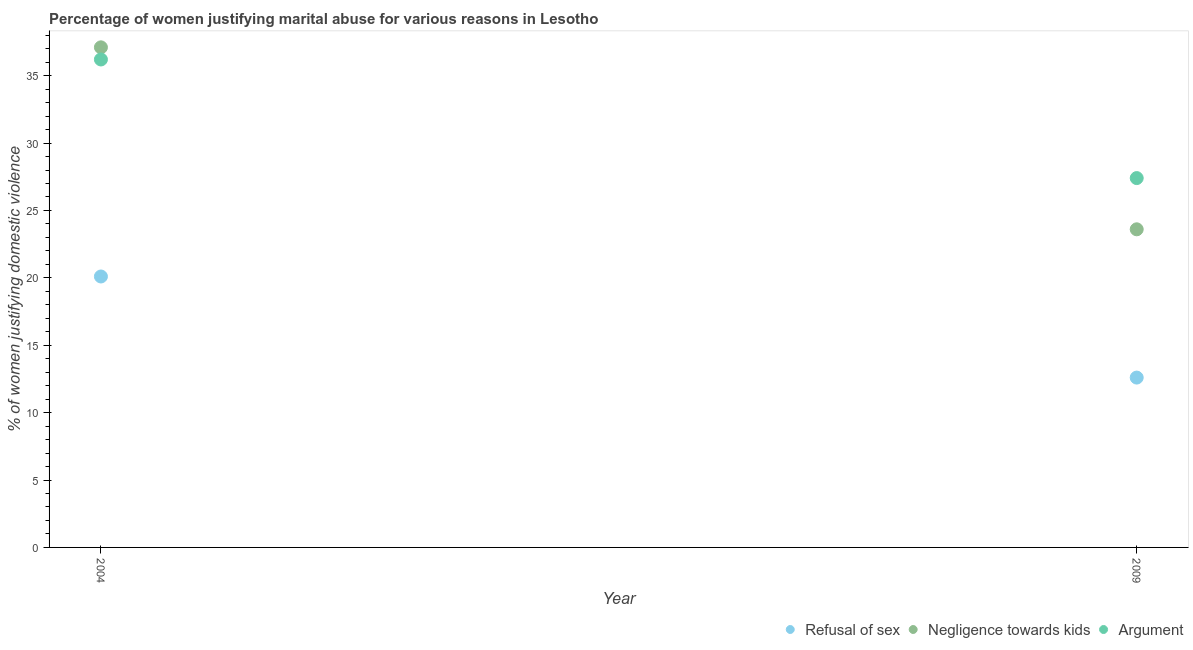Is the number of dotlines equal to the number of legend labels?
Provide a short and direct response. Yes. What is the percentage of women justifying domestic violence due to refusal of sex in 2004?
Your answer should be very brief. 20.1. Across all years, what is the maximum percentage of women justifying domestic violence due to refusal of sex?
Your response must be concise. 20.1. Across all years, what is the minimum percentage of women justifying domestic violence due to negligence towards kids?
Offer a terse response. 23.6. In which year was the percentage of women justifying domestic violence due to arguments maximum?
Make the answer very short. 2004. In which year was the percentage of women justifying domestic violence due to arguments minimum?
Make the answer very short. 2009. What is the total percentage of women justifying domestic violence due to arguments in the graph?
Your answer should be compact. 63.6. What is the difference between the percentage of women justifying domestic violence due to refusal of sex in 2009 and the percentage of women justifying domestic violence due to negligence towards kids in 2004?
Offer a terse response. -24.5. What is the average percentage of women justifying domestic violence due to arguments per year?
Ensure brevity in your answer.  31.8. In the year 2009, what is the difference between the percentage of women justifying domestic violence due to negligence towards kids and percentage of women justifying domestic violence due to refusal of sex?
Provide a short and direct response. 11. What is the ratio of the percentage of women justifying domestic violence due to arguments in 2004 to that in 2009?
Ensure brevity in your answer.  1.32. Is it the case that in every year, the sum of the percentage of women justifying domestic violence due to refusal of sex and percentage of women justifying domestic violence due to negligence towards kids is greater than the percentage of women justifying domestic violence due to arguments?
Your response must be concise. Yes. Does the percentage of women justifying domestic violence due to refusal of sex monotonically increase over the years?
Offer a very short reply. No. How many dotlines are there?
Ensure brevity in your answer.  3. How many years are there in the graph?
Ensure brevity in your answer.  2. What is the difference between two consecutive major ticks on the Y-axis?
Provide a succinct answer. 5. Are the values on the major ticks of Y-axis written in scientific E-notation?
Keep it short and to the point. No. Does the graph contain grids?
Offer a very short reply. No. Where does the legend appear in the graph?
Your answer should be compact. Bottom right. How many legend labels are there?
Ensure brevity in your answer.  3. How are the legend labels stacked?
Make the answer very short. Horizontal. What is the title of the graph?
Ensure brevity in your answer.  Percentage of women justifying marital abuse for various reasons in Lesotho. What is the label or title of the Y-axis?
Give a very brief answer. % of women justifying domestic violence. What is the % of women justifying domestic violence in Refusal of sex in 2004?
Provide a succinct answer. 20.1. What is the % of women justifying domestic violence of Negligence towards kids in 2004?
Ensure brevity in your answer.  37.1. What is the % of women justifying domestic violence of Argument in 2004?
Ensure brevity in your answer.  36.2. What is the % of women justifying domestic violence in Negligence towards kids in 2009?
Keep it short and to the point. 23.6. What is the % of women justifying domestic violence in Argument in 2009?
Keep it short and to the point. 27.4. Across all years, what is the maximum % of women justifying domestic violence of Refusal of sex?
Your answer should be compact. 20.1. Across all years, what is the maximum % of women justifying domestic violence in Negligence towards kids?
Your answer should be very brief. 37.1. Across all years, what is the maximum % of women justifying domestic violence of Argument?
Your answer should be compact. 36.2. Across all years, what is the minimum % of women justifying domestic violence of Negligence towards kids?
Your response must be concise. 23.6. Across all years, what is the minimum % of women justifying domestic violence of Argument?
Ensure brevity in your answer.  27.4. What is the total % of women justifying domestic violence in Refusal of sex in the graph?
Offer a terse response. 32.7. What is the total % of women justifying domestic violence of Negligence towards kids in the graph?
Your answer should be compact. 60.7. What is the total % of women justifying domestic violence of Argument in the graph?
Keep it short and to the point. 63.6. What is the difference between the % of women justifying domestic violence of Negligence towards kids in 2004 and that in 2009?
Your response must be concise. 13.5. What is the difference between the % of women justifying domestic violence of Argument in 2004 and that in 2009?
Provide a short and direct response. 8.8. What is the difference between the % of women justifying domestic violence of Refusal of sex in 2004 and the % of women justifying domestic violence of Negligence towards kids in 2009?
Provide a succinct answer. -3.5. What is the difference between the % of women justifying domestic violence in Refusal of sex in 2004 and the % of women justifying domestic violence in Argument in 2009?
Provide a short and direct response. -7.3. What is the difference between the % of women justifying domestic violence in Negligence towards kids in 2004 and the % of women justifying domestic violence in Argument in 2009?
Your answer should be very brief. 9.7. What is the average % of women justifying domestic violence of Refusal of sex per year?
Keep it short and to the point. 16.35. What is the average % of women justifying domestic violence in Negligence towards kids per year?
Your answer should be very brief. 30.35. What is the average % of women justifying domestic violence of Argument per year?
Your response must be concise. 31.8. In the year 2004, what is the difference between the % of women justifying domestic violence in Refusal of sex and % of women justifying domestic violence in Argument?
Keep it short and to the point. -16.1. In the year 2004, what is the difference between the % of women justifying domestic violence in Negligence towards kids and % of women justifying domestic violence in Argument?
Provide a short and direct response. 0.9. In the year 2009, what is the difference between the % of women justifying domestic violence in Refusal of sex and % of women justifying domestic violence in Argument?
Provide a short and direct response. -14.8. What is the ratio of the % of women justifying domestic violence of Refusal of sex in 2004 to that in 2009?
Ensure brevity in your answer.  1.6. What is the ratio of the % of women justifying domestic violence of Negligence towards kids in 2004 to that in 2009?
Make the answer very short. 1.57. What is the ratio of the % of women justifying domestic violence in Argument in 2004 to that in 2009?
Offer a terse response. 1.32. What is the difference between the highest and the second highest % of women justifying domestic violence of Negligence towards kids?
Make the answer very short. 13.5. What is the difference between the highest and the second highest % of women justifying domestic violence in Argument?
Offer a terse response. 8.8. What is the difference between the highest and the lowest % of women justifying domestic violence of Negligence towards kids?
Provide a short and direct response. 13.5. 